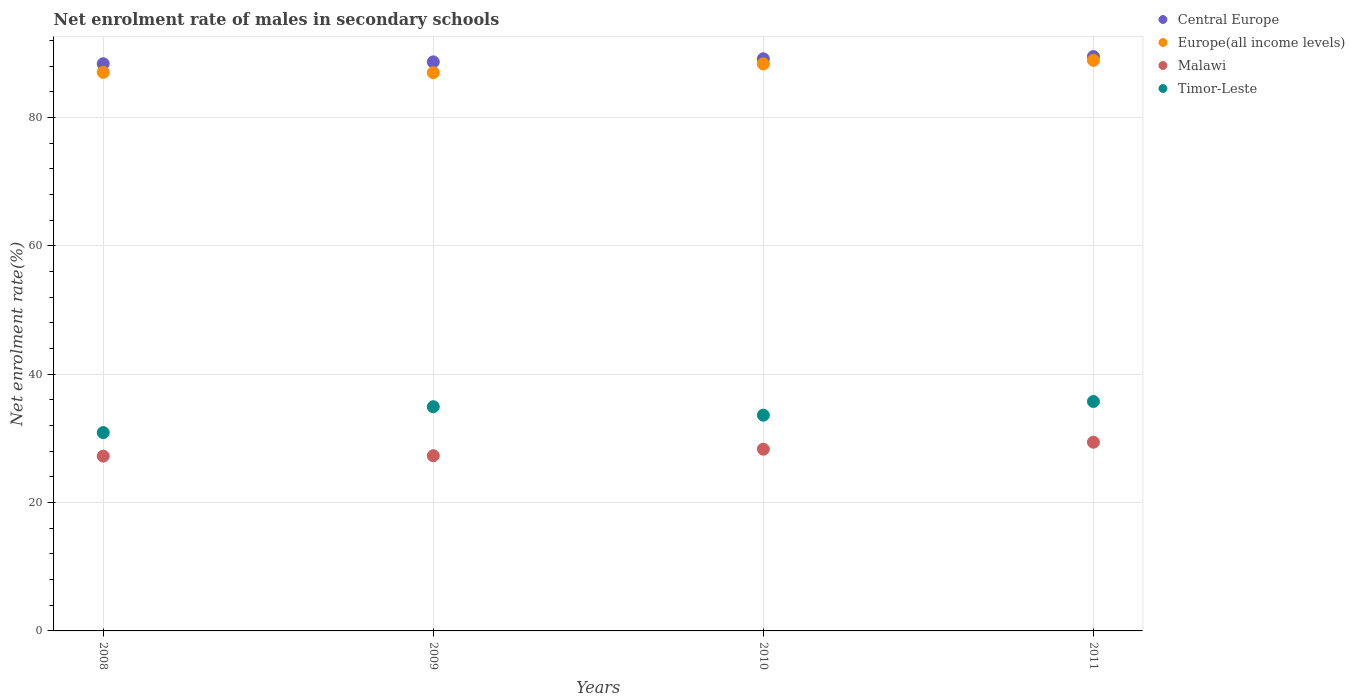How many different coloured dotlines are there?
Offer a very short reply. 4. What is the net enrolment rate of males in secondary schools in Central Europe in 2011?
Keep it short and to the point. 89.51. Across all years, what is the maximum net enrolment rate of males in secondary schools in Malawi?
Keep it short and to the point. 29.41. Across all years, what is the minimum net enrolment rate of males in secondary schools in Timor-Leste?
Your answer should be very brief. 30.91. What is the total net enrolment rate of males in secondary schools in Timor-Leste in the graph?
Provide a succinct answer. 135.22. What is the difference between the net enrolment rate of males in secondary schools in Central Europe in 2009 and that in 2011?
Give a very brief answer. -0.83. What is the difference between the net enrolment rate of males in secondary schools in Europe(all income levels) in 2009 and the net enrolment rate of males in secondary schools in Timor-Leste in 2008?
Your answer should be compact. 56.09. What is the average net enrolment rate of males in secondary schools in Malawi per year?
Give a very brief answer. 28.07. In the year 2008, what is the difference between the net enrolment rate of males in secondary schools in Timor-Leste and net enrolment rate of males in secondary schools in Central Europe?
Your answer should be compact. -57.48. In how many years, is the net enrolment rate of males in secondary schools in Europe(all income levels) greater than 72 %?
Provide a short and direct response. 4. What is the ratio of the net enrolment rate of males in secondary schools in Timor-Leste in 2008 to that in 2011?
Your response must be concise. 0.86. Is the net enrolment rate of males in secondary schools in Central Europe in 2009 less than that in 2011?
Offer a terse response. Yes. What is the difference between the highest and the second highest net enrolment rate of males in secondary schools in Central Europe?
Offer a very short reply. 0.35. What is the difference between the highest and the lowest net enrolment rate of males in secondary schools in Europe(all income levels)?
Your response must be concise. 1.92. In how many years, is the net enrolment rate of males in secondary schools in Malawi greater than the average net enrolment rate of males in secondary schools in Malawi taken over all years?
Give a very brief answer. 2. Does the net enrolment rate of males in secondary schools in Malawi monotonically increase over the years?
Keep it short and to the point. Yes. Is the net enrolment rate of males in secondary schools in Europe(all income levels) strictly greater than the net enrolment rate of males in secondary schools in Malawi over the years?
Keep it short and to the point. Yes. Is the net enrolment rate of males in secondary schools in Central Europe strictly less than the net enrolment rate of males in secondary schools in Malawi over the years?
Ensure brevity in your answer.  No. What is the difference between two consecutive major ticks on the Y-axis?
Keep it short and to the point. 20. Are the values on the major ticks of Y-axis written in scientific E-notation?
Make the answer very short. No. Does the graph contain any zero values?
Ensure brevity in your answer.  No. Does the graph contain grids?
Provide a succinct answer. Yes. How are the legend labels stacked?
Provide a succinct answer. Vertical. What is the title of the graph?
Provide a short and direct response. Net enrolment rate of males in secondary schools. Does "Faeroe Islands" appear as one of the legend labels in the graph?
Your answer should be compact. No. What is the label or title of the X-axis?
Make the answer very short. Years. What is the label or title of the Y-axis?
Keep it short and to the point. Net enrolment rate(%). What is the Net enrolment rate(%) in Central Europe in 2008?
Give a very brief answer. 88.39. What is the Net enrolment rate(%) in Europe(all income levels) in 2008?
Offer a terse response. 87.05. What is the Net enrolment rate(%) of Malawi in 2008?
Keep it short and to the point. 27.24. What is the Net enrolment rate(%) of Timor-Leste in 2008?
Provide a succinct answer. 30.91. What is the Net enrolment rate(%) of Central Europe in 2009?
Your response must be concise. 88.68. What is the Net enrolment rate(%) of Europe(all income levels) in 2009?
Make the answer very short. 87. What is the Net enrolment rate(%) in Malawi in 2009?
Offer a terse response. 27.3. What is the Net enrolment rate(%) in Timor-Leste in 2009?
Make the answer very short. 34.93. What is the Net enrolment rate(%) of Central Europe in 2010?
Your response must be concise. 89.16. What is the Net enrolment rate(%) in Europe(all income levels) in 2010?
Offer a very short reply. 88.36. What is the Net enrolment rate(%) of Malawi in 2010?
Make the answer very short. 28.32. What is the Net enrolment rate(%) in Timor-Leste in 2010?
Your answer should be very brief. 33.62. What is the Net enrolment rate(%) of Central Europe in 2011?
Provide a short and direct response. 89.51. What is the Net enrolment rate(%) of Europe(all income levels) in 2011?
Offer a terse response. 88.92. What is the Net enrolment rate(%) in Malawi in 2011?
Your response must be concise. 29.41. What is the Net enrolment rate(%) of Timor-Leste in 2011?
Your answer should be compact. 35.75. Across all years, what is the maximum Net enrolment rate(%) of Central Europe?
Your answer should be very brief. 89.51. Across all years, what is the maximum Net enrolment rate(%) in Europe(all income levels)?
Your response must be concise. 88.92. Across all years, what is the maximum Net enrolment rate(%) in Malawi?
Provide a short and direct response. 29.41. Across all years, what is the maximum Net enrolment rate(%) of Timor-Leste?
Provide a succinct answer. 35.75. Across all years, what is the minimum Net enrolment rate(%) of Central Europe?
Your answer should be very brief. 88.39. Across all years, what is the minimum Net enrolment rate(%) of Europe(all income levels)?
Give a very brief answer. 87. Across all years, what is the minimum Net enrolment rate(%) of Malawi?
Ensure brevity in your answer.  27.24. Across all years, what is the minimum Net enrolment rate(%) in Timor-Leste?
Give a very brief answer. 30.91. What is the total Net enrolment rate(%) in Central Europe in the graph?
Offer a very short reply. 355.73. What is the total Net enrolment rate(%) of Europe(all income levels) in the graph?
Give a very brief answer. 351.33. What is the total Net enrolment rate(%) in Malawi in the graph?
Offer a very short reply. 112.27. What is the total Net enrolment rate(%) in Timor-Leste in the graph?
Make the answer very short. 135.22. What is the difference between the Net enrolment rate(%) of Central Europe in 2008 and that in 2009?
Keep it short and to the point. -0.29. What is the difference between the Net enrolment rate(%) of Europe(all income levels) in 2008 and that in 2009?
Your answer should be very brief. 0.05. What is the difference between the Net enrolment rate(%) in Malawi in 2008 and that in 2009?
Offer a very short reply. -0.06. What is the difference between the Net enrolment rate(%) in Timor-Leste in 2008 and that in 2009?
Keep it short and to the point. -4.03. What is the difference between the Net enrolment rate(%) of Central Europe in 2008 and that in 2010?
Offer a very short reply. -0.77. What is the difference between the Net enrolment rate(%) in Europe(all income levels) in 2008 and that in 2010?
Ensure brevity in your answer.  -1.31. What is the difference between the Net enrolment rate(%) in Malawi in 2008 and that in 2010?
Make the answer very short. -1.08. What is the difference between the Net enrolment rate(%) in Timor-Leste in 2008 and that in 2010?
Provide a short and direct response. -2.72. What is the difference between the Net enrolment rate(%) of Central Europe in 2008 and that in 2011?
Your response must be concise. -1.12. What is the difference between the Net enrolment rate(%) in Europe(all income levels) in 2008 and that in 2011?
Offer a very short reply. -1.87. What is the difference between the Net enrolment rate(%) of Malawi in 2008 and that in 2011?
Ensure brevity in your answer.  -2.17. What is the difference between the Net enrolment rate(%) in Timor-Leste in 2008 and that in 2011?
Ensure brevity in your answer.  -4.84. What is the difference between the Net enrolment rate(%) of Central Europe in 2009 and that in 2010?
Your answer should be very brief. -0.48. What is the difference between the Net enrolment rate(%) in Europe(all income levels) in 2009 and that in 2010?
Your answer should be compact. -1.36. What is the difference between the Net enrolment rate(%) in Malawi in 2009 and that in 2010?
Keep it short and to the point. -1.01. What is the difference between the Net enrolment rate(%) of Timor-Leste in 2009 and that in 2010?
Offer a very short reply. 1.31. What is the difference between the Net enrolment rate(%) of Central Europe in 2009 and that in 2011?
Provide a short and direct response. -0.83. What is the difference between the Net enrolment rate(%) of Europe(all income levels) in 2009 and that in 2011?
Offer a terse response. -1.92. What is the difference between the Net enrolment rate(%) of Malawi in 2009 and that in 2011?
Make the answer very short. -2.1. What is the difference between the Net enrolment rate(%) in Timor-Leste in 2009 and that in 2011?
Offer a very short reply. -0.82. What is the difference between the Net enrolment rate(%) of Central Europe in 2010 and that in 2011?
Your answer should be very brief. -0.35. What is the difference between the Net enrolment rate(%) in Europe(all income levels) in 2010 and that in 2011?
Give a very brief answer. -0.56. What is the difference between the Net enrolment rate(%) of Malawi in 2010 and that in 2011?
Your answer should be compact. -1.09. What is the difference between the Net enrolment rate(%) in Timor-Leste in 2010 and that in 2011?
Offer a terse response. -2.13. What is the difference between the Net enrolment rate(%) of Central Europe in 2008 and the Net enrolment rate(%) of Europe(all income levels) in 2009?
Give a very brief answer. 1.39. What is the difference between the Net enrolment rate(%) in Central Europe in 2008 and the Net enrolment rate(%) in Malawi in 2009?
Make the answer very short. 61.08. What is the difference between the Net enrolment rate(%) in Central Europe in 2008 and the Net enrolment rate(%) in Timor-Leste in 2009?
Your answer should be very brief. 53.45. What is the difference between the Net enrolment rate(%) of Europe(all income levels) in 2008 and the Net enrolment rate(%) of Malawi in 2009?
Make the answer very short. 59.74. What is the difference between the Net enrolment rate(%) of Europe(all income levels) in 2008 and the Net enrolment rate(%) of Timor-Leste in 2009?
Offer a very short reply. 52.11. What is the difference between the Net enrolment rate(%) in Malawi in 2008 and the Net enrolment rate(%) in Timor-Leste in 2009?
Keep it short and to the point. -7.69. What is the difference between the Net enrolment rate(%) of Central Europe in 2008 and the Net enrolment rate(%) of Europe(all income levels) in 2010?
Give a very brief answer. 0.03. What is the difference between the Net enrolment rate(%) in Central Europe in 2008 and the Net enrolment rate(%) in Malawi in 2010?
Ensure brevity in your answer.  60.07. What is the difference between the Net enrolment rate(%) of Central Europe in 2008 and the Net enrolment rate(%) of Timor-Leste in 2010?
Make the answer very short. 54.76. What is the difference between the Net enrolment rate(%) in Europe(all income levels) in 2008 and the Net enrolment rate(%) in Malawi in 2010?
Your answer should be compact. 58.73. What is the difference between the Net enrolment rate(%) in Europe(all income levels) in 2008 and the Net enrolment rate(%) in Timor-Leste in 2010?
Provide a short and direct response. 53.43. What is the difference between the Net enrolment rate(%) in Malawi in 2008 and the Net enrolment rate(%) in Timor-Leste in 2010?
Offer a terse response. -6.38. What is the difference between the Net enrolment rate(%) of Central Europe in 2008 and the Net enrolment rate(%) of Europe(all income levels) in 2011?
Ensure brevity in your answer.  -0.53. What is the difference between the Net enrolment rate(%) in Central Europe in 2008 and the Net enrolment rate(%) in Malawi in 2011?
Provide a succinct answer. 58.98. What is the difference between the Net enrolment rate(%) in Central Europe in 2008 and the Net enrolment rate(%) in Timor-Leste in 2011?
Offer a terse response. 52.63. What is the difference between the Net enrolment rate(%) of Europe(all income levels) in 2008 and the Net enrolment rate(%) of Malawi in 2011?
Provide a succinct answer. 57.64. What is the difference between the Net enrolment rate(%) in Europe(all income levels) in 2008 and the Net enrolment rate(%) in Timor-Leste in 2011?
Ensure brevity in your answer.  51.3. What is the difference between the Net enrolment rate(%) of Malawi in 2008 and the Net enrolment rate(%) of Timor-Leste in 2011?
Offer a terse response. -8.51. What is the difference between the Net enrolment rate(%) in Central Europe in 2009 and the Net enrolment rate(%) in Europe(all income levels) in 2010?
Ensure brevity in your answer.  0.32. What is the difference between the Net enrolment rate(%) of Central Europe in 2009 and the Net enrolment rate(%) of Malawi in 2010?
Your answer should be compact. 60.36. What is the difference between the Net enrolment rate(%) in Central Europe in 2009 and the Net enrolment rate(%) in Timor-Leste in 2010?
Ensure brevity in your answer.  55.06. What is the difference between the Net enrolment rate(%) of Europe(all income levels) in 2009 and the Net enrolment rate(%) of Malawi in 2010?
Provide a succinct answer. 58.68. What is the difference between the Net enrolment rate(%) in Europe(all income levels) in 2009 and the Net enrolment rate(%) in Timor-Leste in 2010?
Your answer should be very brief. 53.38. What is the difference between the Net enrolment rate(%) of Malawi in 2009 and the Net enrolment rate(%) of Timor-Leste in 2010?
Your response must be concise. -6.32. What is the difference between the Net enrolment rate(%) of Central Europe in 2009 and the Net enrolment rate(%) of Europe(all income levels) in 2011?
Provide a short and direct response. -0.24. What is the difference between the Net enrolment rate(%) of Central Europe in 2009 and the Net enrolment rate(%) of Malawi in 2011?
Make the answer very short. 59.27. What is the difference between the Net enrolment rate(%) of Central Europe in 2009 and the Net enrolment rate(%) of Timor-Leste in 2011?
Keep it short and to the point. 52.93. What is the difference between the Net enrolment rate(%) in Europe(all income levels) in 2009 and the Net enrolment rate(%) in Malawi in 2011?
Provide a short and direct response. 57.59. What is the difference between the Net enrolment rate(%) of Europe(all income levels) in 2009 and the Net enrolment rate(%) of Timor-Leste in 2011?
Give a very brief answer. 51.25. What is the difference between the Net enrolment rate(%) of Malawi in 2009 and the Net enrolment rate(%) of Timor-Leste in 2011?
Provide a succinct answer. -8.45. What is the difference between the Net enrolment rate(%) of Central Europe in 2010 and the Net enrolment rate(%) of Europe(all income levels) in 2011?
Your response must be concise. 0.24. What is the difference between the Net enrolment rate(%) in Central Europe in 2010 and the Net enrolment rate(%) in Malawi in 2011?
Provide a succinct answer. 59.75. What is the difference between the Net enrolment rate(%) in Central Europe in 2010 and the Net enrolment rate(%) in Timor-Leste in 2011?
Provide a short and direct response. 53.4. What is the difference between the Net enrolment rate(%) in Europe(all income levels) in 2010 and the Net enrolment rate(%) in Malawi in 2011?
Your answer should be very brief. 58.95. What is the difference between the Net enrolment rate(%) in Europe(all income levels) in 2010 and the Net enrolment rate(%) in Timor-Leste in 2011?
Provide a short and direct response. 52.61. What is the difference between the Net enrolment rate(%) in Malawi in 2010 and the Net enrolment rate(%) in Timor-Leste in 2011?
Offer a terse response. -7.43. What is the average Net enrolment rate(%) of Central Europe per year?
Your answer should be very brief. 88.93. What is the average Net enrolment rate(%) of Europe(all income levels) per year?
Ensure brevity in your answer.  87.83. What is the average Net enrolment rate(%) in Malawi per year?
Offer a terse response. 28.07. What is the average Net enrolment rate(%) of Timor-Leste per year?
Provide a short and direct response. 33.8. In the year 2008, what is the difference between the Net enrolment rate(%) of Central Europe and Net enrolment rate(%) of Europe(all income levels)?
Offer a very short reply. 1.34. In the year 2008, what is the difference between the Net enrolment rate(%) of Central Europe and Net enrolment rate(%) of Malawi?
Offer a terse response. 61.15. In the year 2008, what is the difference between the Net enrolment rate(%) in Central Europe and Net enrolment rate(%) in Timor-Leste?
Provide a succinct answer. 57.48. In the year 2008, what is the difference between the Net enrolment rate(%) in Europe(all income levels) and Net enrolment rate(%) in Malawi?
Your answer should be compact. 59.81. In the year 2008, what is the difference between the Net enrolment rate(%) of Europe(all income levels) and Net enrolment rate(%) of Timor-Leste?
Give a very brief answer. 56.14. In the year 2008, what is the difference between the Net enrolment rate(%) of Malawi and Net enrolment rate(%) of Timor-Leste?
Your response must be concise. -3.67. In the year 2009, what is the difference between the Net enrolment rate(%) in Central Europe and Net enrolment rate(%) in Europe(all income levels)?
Your answer should be compact. 1.68. In the year 2009, what is the difference between the Net enrolment rate(%) in Central Europe and Net enrolment rate(%) in Malawi?
Ensure brevity in your answer.  61.37. In the year 2009, what is the difference between the Net enrolment rate(%) of Central Europe and Net enrolment rate(%) of Timor-Leste?
Your answer should be very brief. 53.74. In the year 2009, what is the difference between the Net enrolment rate(%) of Europe(all income levels) and Net enrolment rate(%) of Malawi?
Your answer should be compact. 59.7. In the year 2009, what is the difference between the Net enrolment rate(%) in Europe(all income levels) and Net enrolment rate(%) in Timor-Leste?
Your answer should be compact. 52.07. In the year 2009, what is the difference between the Net enrolment rate(%) of Malawi and Net enrolment rate(%) of Timor-Leste?
Provide a succinct answer. -7.63. In the year 2010, what is the difference between the Net enrolment rate(%) in Central Europe and Net enrolment rate(%) in Europe(all income levels)?
Give a very brief answer. 0.79. In the year 2010, what is the difference between the Net enrolment rate(%) of Central Europe and Net enrolment rate(%) of Malawi?
Offer a very short reply. 60.84. In the year 2010, what is the difference between the Net enrolment rate(%) in Central Europe and Net enrolment rate(%) in Timor-Leste?
Offer a terse response. 55.53. In the year 2010, what is the difference between the Net enrolment rate(%) of Europe(all income levels) and Net enrolment rate(%) of Malawi?
Ensure brevity in your answer.  60.04. In the year 2010, what is the difference between the Net enrolment rate(%) in Europe(all income levels) and Net enrolment rate(%) in Timor-Leste?
Provide a short and direct response. 54.74. In the year 2010, what is the difference between the Net enrolment rate(%) of Malawi and Net enrolment rate(%) of Timor-Leste?
Offer a very short reply. -5.3. In the year 2011, what is the difference between the Net enrolment rate(%) in Central Europe and Net enrolment rate(%) in Europe(all income levels)?
Make the answer very short. 0.59. In the year 2011, what is the difference between the Net enrolment rate(%) in Central Europe and Net enrolment rate(%) in Malawi?
Keep it short and to the point. 60.1. In the year 2011, what is the difference between the Net enrolment rate(%) in Central Europe and Net enrolment rate(%) in Timor-Leste?
Make the answer very short. 53.75. In the year 2011, what is the difference between the Net enrolment rate(%) of Europe(all income levels) and Net enrolment rate(%) of Malawi?
Your answer should be very brief. 59.51. In the year 2011, what is the difference between the Net enrolment rate(%) in Europe(all income levels) and Net enrolment rate(%) in Timor-Leste?
Ensure brevity in your answer.  53.17. In the year 2011, what is the difference between the Net enrolment rate(%) of Malawi and Net enrolment rate(%) of Timor-Leste?
Your answer should be very brief. -6.35. What is the ratio of the Net enrolment rate(%) in Central Europe in 2008 to that in 2009?
Give a very brief answer. 1. What is the ratio of the Net enrolment rate(%) of Timor-Leste in 2008 to that in 2009?
Make the answer very short. 0.88. What is the ratio of the Net enrolment rate(%) of Central Europe in 2008 to that in 2010?
Your response must be concise. 0.99. What is the ratio of the Net enrolment rate(%) of Europe(all income levels) in 2008 to that in 2010?
Your response must be concise. 0.99. What is the ratio of the Net enrolment rate(%) in Timor-Leste in 2008 to that in 2010?
Offer a terse response. 0.92. What is the ratio of the Net enrolment rate(%) of Central Europe in 2008 to that in 2011?
Make the answer very short. 0.99. What is the ratio of the Net enrolment rate(%) in Malawi in 2008 to that in 2011?
Keep it short and to the point. 0.93. What is the ratio of the Net enrolment rate(%) in Timor-Leste in 2008 to that in 2011?
Offer a terse response. 0.86. What is the ratio of the Net enrolment rate(%) in Europe(all income levels) in 2009 to that in 2010?
Ensure brevity in your answer.  0.98. What is the ratio of the Net enrolment rate(%) of Malawi in 2009 to that in 2010?
Offer a terse response. 0.96. What is the ratio of the Net enrolment rate(%) in Timor-Leste in 2009 to that in 2010?
Your answer should be compact. 1.04. What is the ratio of the Net enrolment rate(%) in Central Europe in 2009 to that in 2011?
Offer a very short reply. 0.99. What is the ratio of the Net enrolment rate(%) of Europe(all income levels) in 2009 to that in 2011?
Keep it short and to the point. 0.98. What is the ratio of the Net enrolment rate(%) in Malawi in 2009 to that in 2011?
Offer a very short reply. 0.93. What is the ratio of the Net enrolment rate(%) in Timor-Leste in 2009 to that in 2011?
Offer a terse response. 0.98. What is the ratio of the Net enrolment rate(%) in Europe(all income levels) in 2010 to that in 2011?
Give a very brief answer. 0.99. What is the ratio of the Net enrolment rate(%) in Timor-Leste in 2010 to that in 2011?
Your response must be concise. 0.94. What is the difference between the highest and the second highest Net enrolment rate(%) of Central Europe?
Keep it short and to the point. 0.35. What is the difference between the highest and the second highest Net enrolment rate(%) of Europe(all income levels)?
Offer a terse response. 0.56. What is the difference between the highest and the second highest Net enrolment rate(%) in Malawi?
Provide a short and direct response. 1.09. What is the difference between the highest and the second highest Net enrolment rate(%) of Timor-Leste?
Make the answer very short. 0.82. What is the difference between the highest and the lowest Net enrolment rate(%) in Central Europe?
Provide a succinct answer. 1.12. What is the difference between the highest and the lowest Net enrolment rate(%) in Europe(all income levels)?
Give a very brief answer. 1.92. What is the difference between the highest and the lowest Net enrolment rate(%) of Malawi?
Your answer should be compact. 2.17. What is the difference between the highest and the lowest Net enrolment rate(%) of Timor-Leste?
Give a very brief answer. 4.84. 